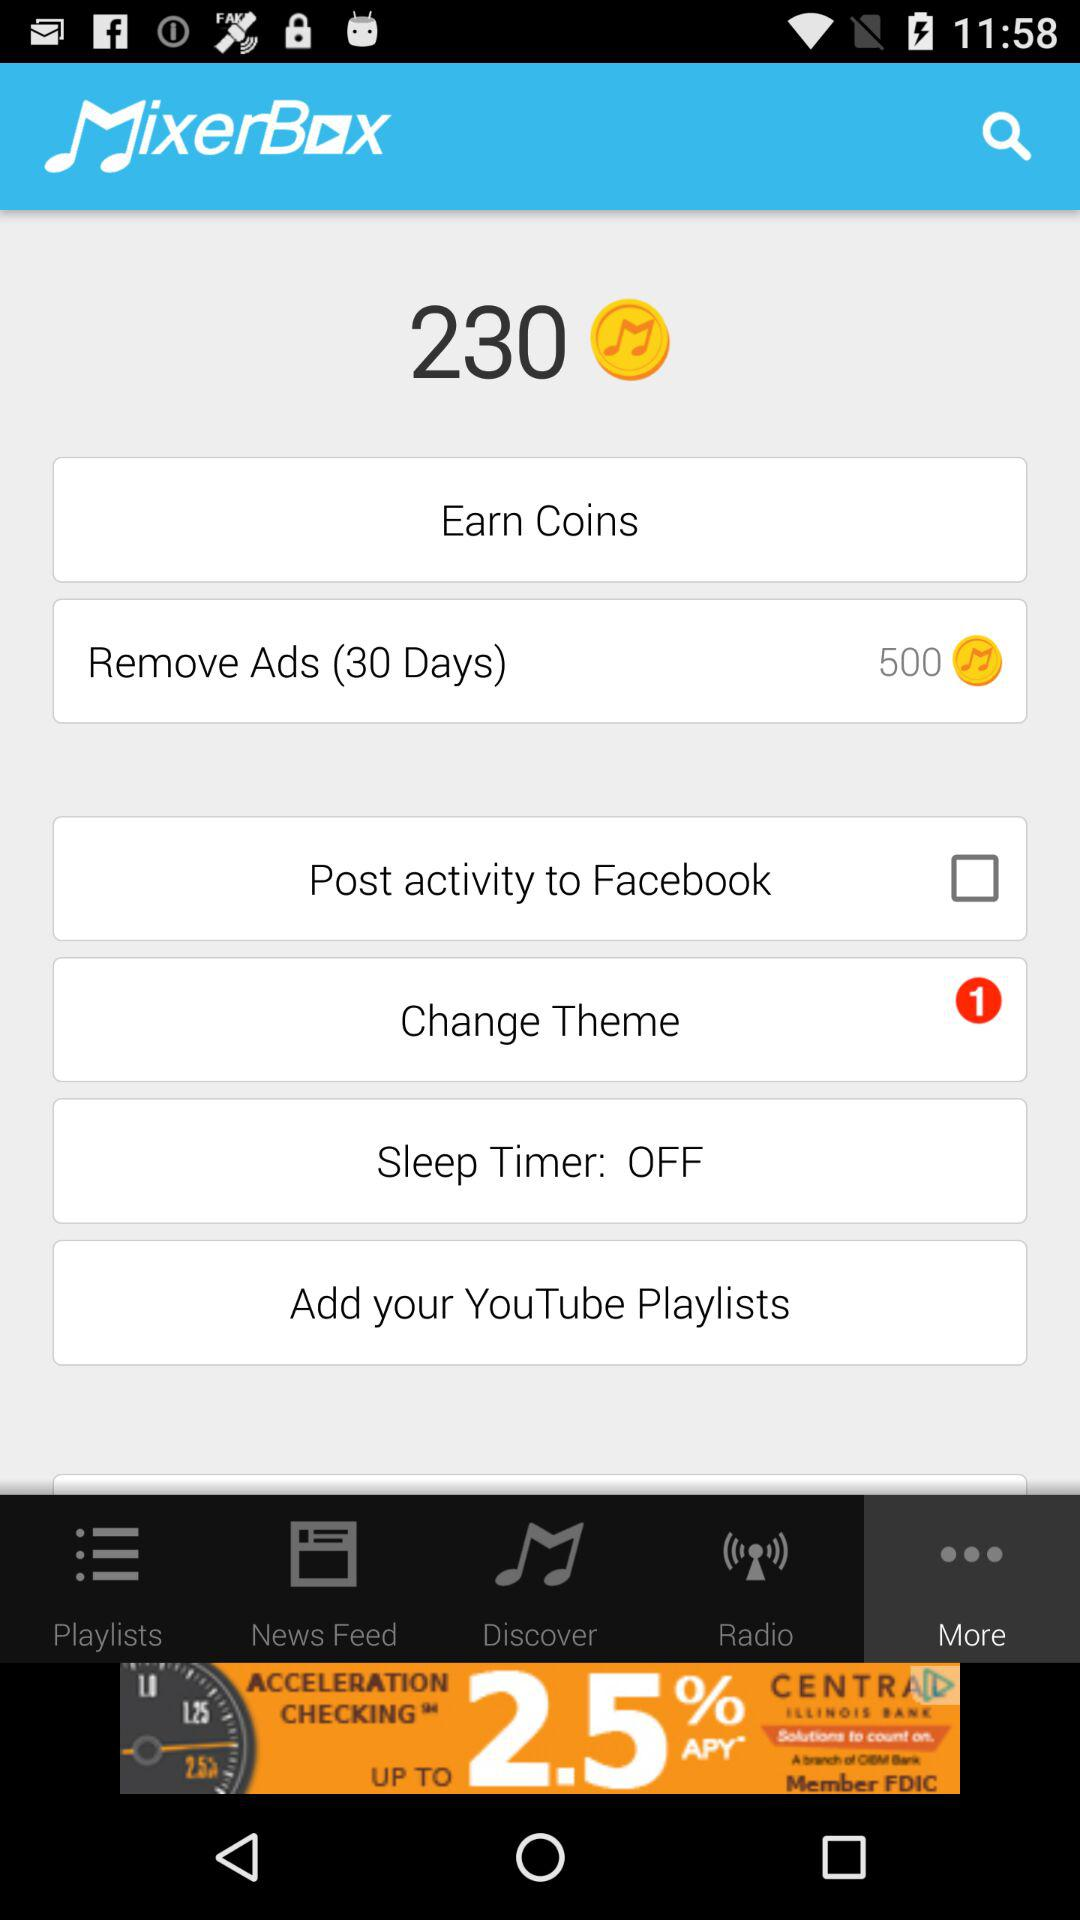For how long can the ads be removed? The ads can be removed for 30 days. 